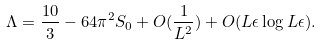Convert formula to latex. <formula><loc_0><loc_0><loc_500><loc_500>\Lambda = \frac { 1 0 } { 3 } - 6 4 \pi ^ { 2 } S _ { 0 } + O ( \frac { 1 } { L ^ { 2 } } ) + O ( L \epsilon \log L \epsilon ) .</formula> 